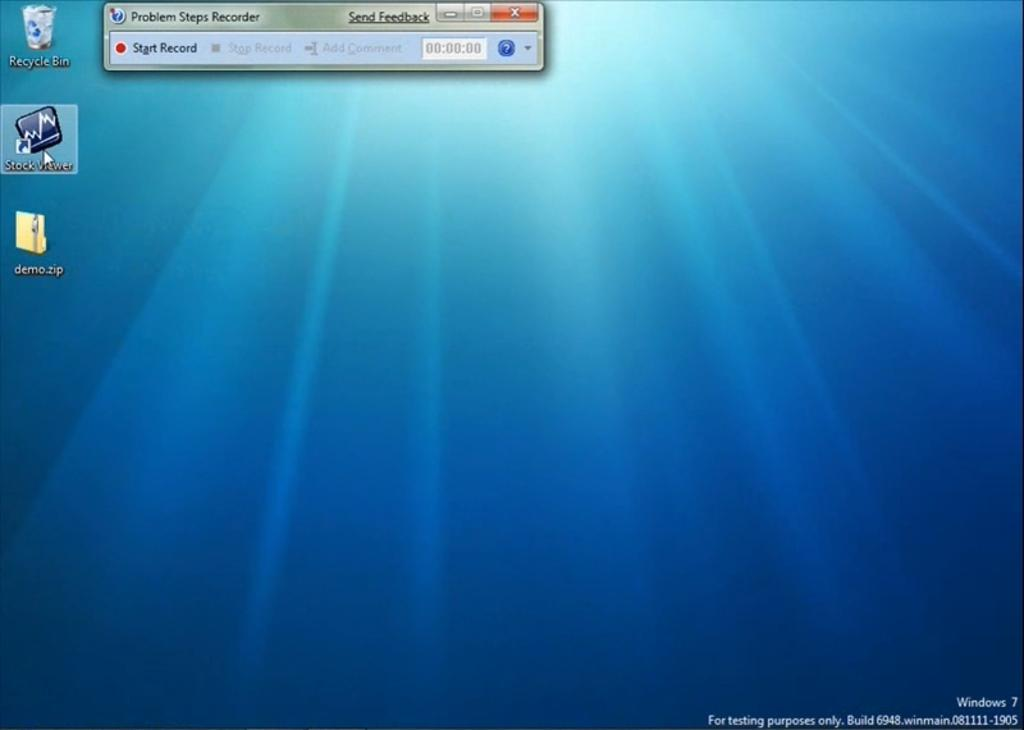<image>
Summarize the visual content of the image. Blue computer screen that says "Problems Steps Recorder". 